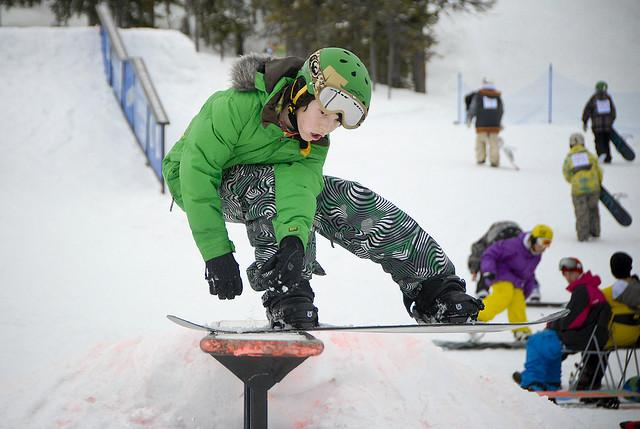Who watches these people while they board on snow?

Choices:
A) judges
B) coal miners
C) no one
D) enemies judges 